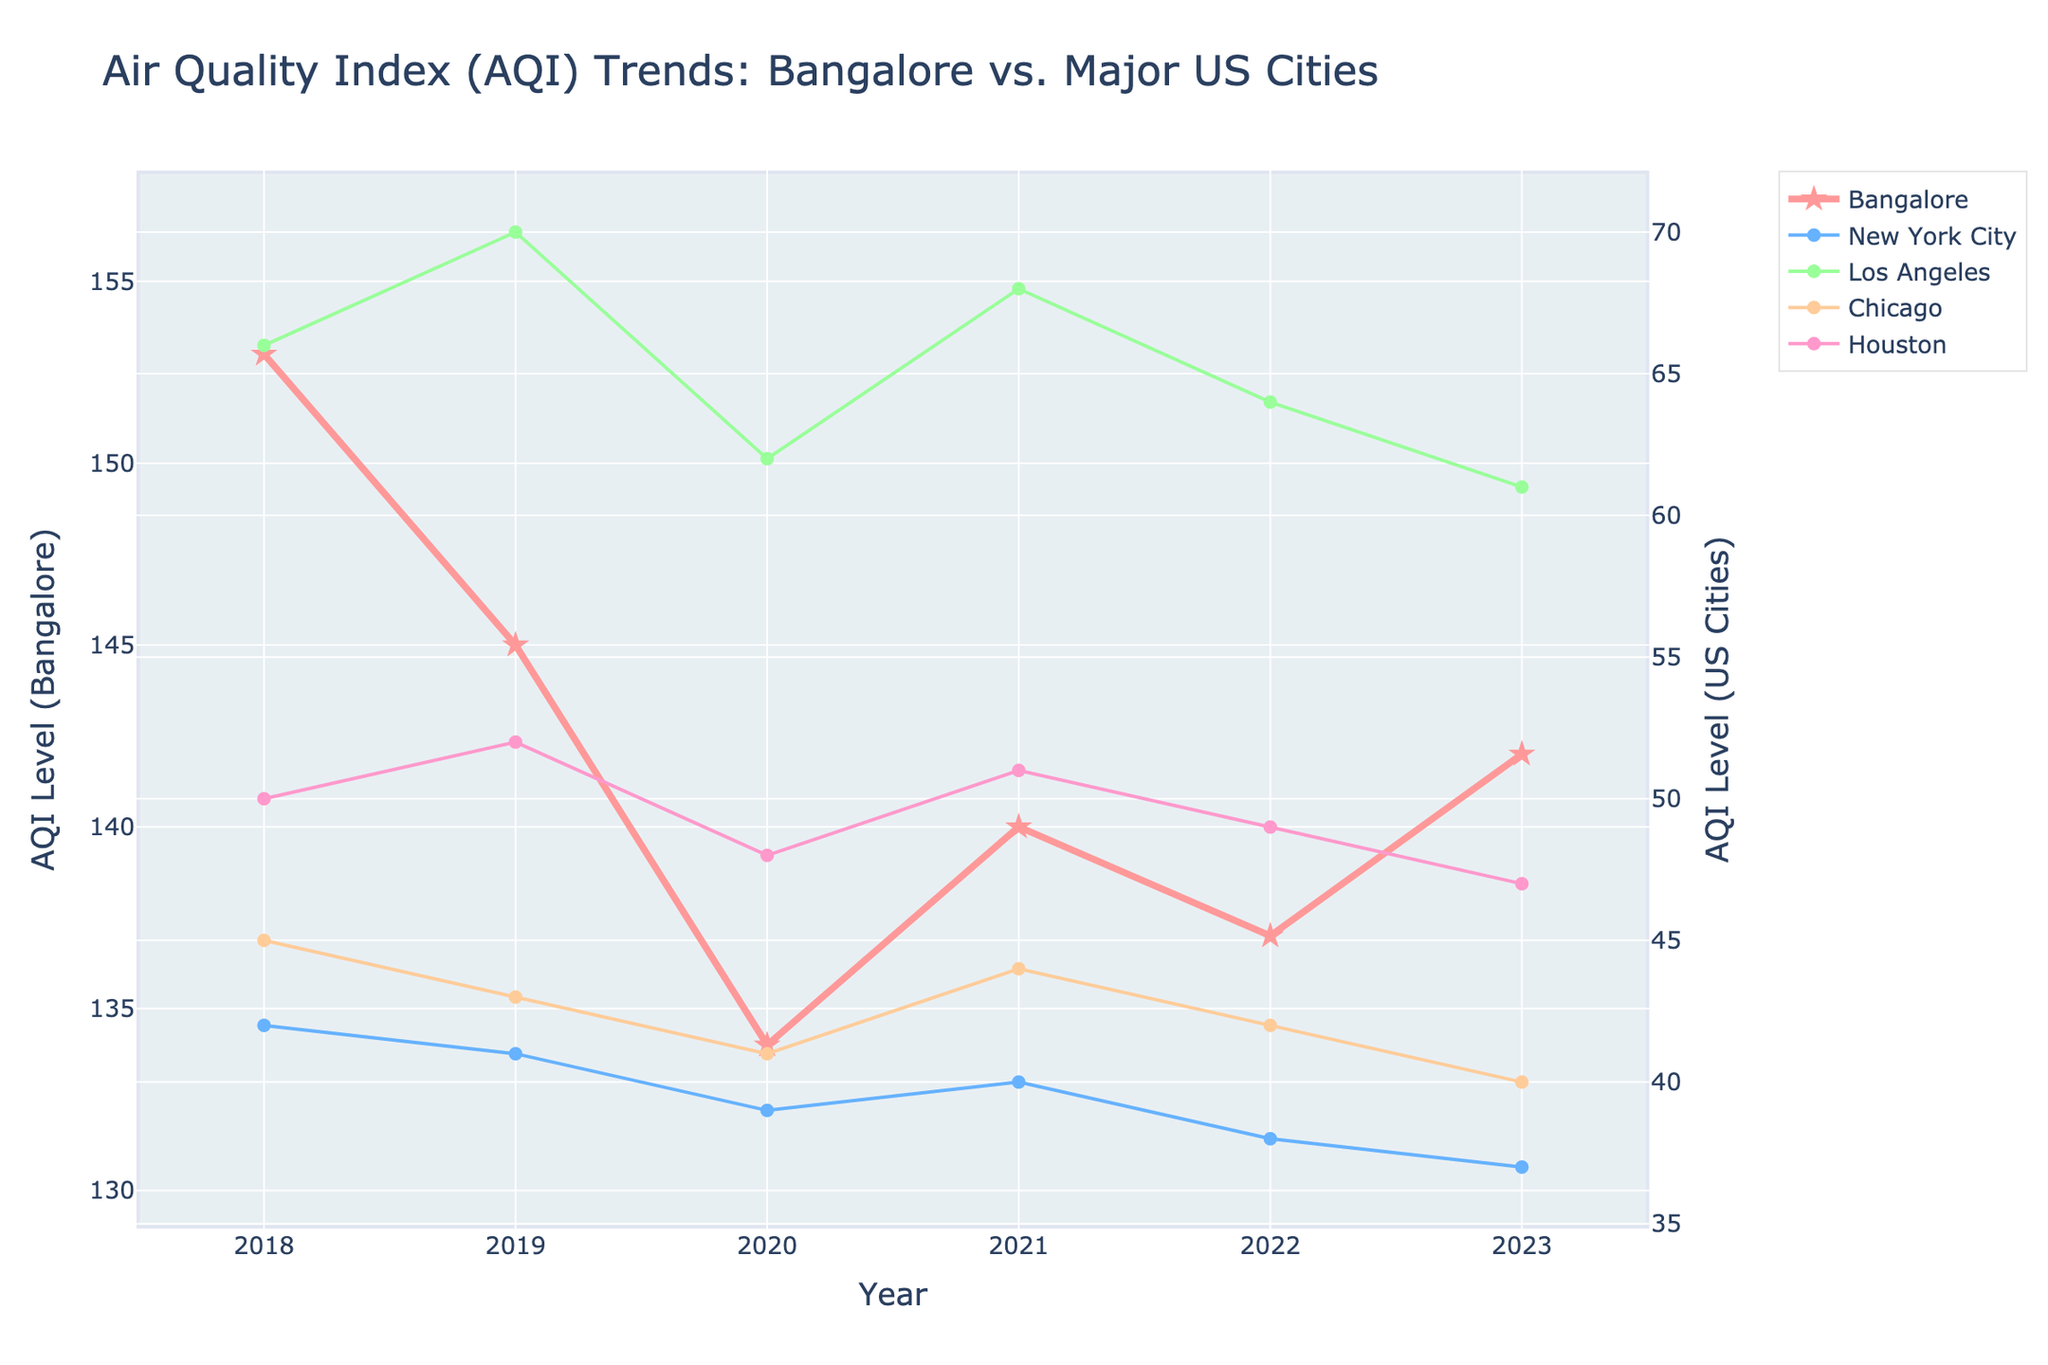What's the overall trend for Bangalore's AQI over the last 5 years? To find the overall trend, observe how the AQI values change each year. Starting from 2018 with 153, they decrease to 134 in 2020, then slightly increase to 142 in 2023. So, the trend is a slight decrease followed by a slight increase.
Answer: Slight decrease then slight increase How does Bangalore's AQI in 2023 compare to its AQI in 2018? Compare the AQI values of Bangalore for the years 2018 and 2023. In 2018, it's 153, and in 2023, it's 142. The AQI has decreased.
Answer: Decreased Which US city had the lowest AQI in 2023? Look at the AQI values for 2023 for all US cities and find the smallest one. New York City has the lowest AQI value of 37.
Answer: New York City What is the difference between the highest and lowest AQI values for Bangalore over the last 5 years? Identify the highest and lowest AQI values for Bangalore from 2018 to 2023. The highest is 153 (2018), and the lowest is 134 (2020). The difference is 153 - 134 = 19.
Answer: 19 Which city showed the most consistent AQI levels over the last 5 years? The most consistent city will have the least variation in AQI values each year. Inspect the data trends for all cities. New York City has the least variation in AQI with values ranging from 37 to 42.
Answer: New York City How did the AQI for Los Angeles change from 2018 to 2019? Look at the AQI values of Los Angeles for 2018 and 2019. In 2018, it is 66, and in 2019, it increases to 70.
Answer: Increased What is the average AQI for Chicago from 2018 to 2023? Sum the AQI values for Chicago from 2018 to 2023 and divide by the number of years: (45+43+41+44+42+40)/6. The average is 42.5.
Answer: 42.5 How does Houston's AQI in 2022 compare to its AQI in 2023? Compare the AQI values of Houston for 2022 and 2023. It is 49 in 2022 and drops to 47 in 2023.
Answer: Decreased Did any US city ever exceed an AQI of 70 in the last 5 years? Examine the AQI values of all US cities from 2018 to 2023. All values are equal to or below 70, with Los Angeles having a peak of 70 in 2019, but never exceeding it.
Answer: No What is the combined total AQI for Houston and Chicago in 2021? Sum the AQI values of Houston and Chicago for the year 2021. Houston's AQI is 51 and Chicago's is 44, so the total is 51 + 44 = 95.
Answer: 95 